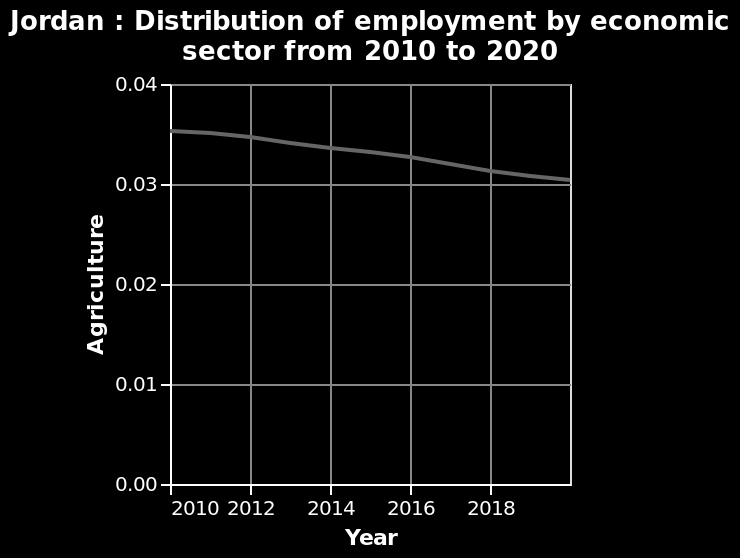<image>
What does the x-axis represent in the area diagram? The x-axis represents the years from 2010 to 2018. How does the employment situation in agriculture compare to previous years in 2018? The employment situation in agriculture in 2018 is similar to the previous years, showing a stable and flattened trend. 